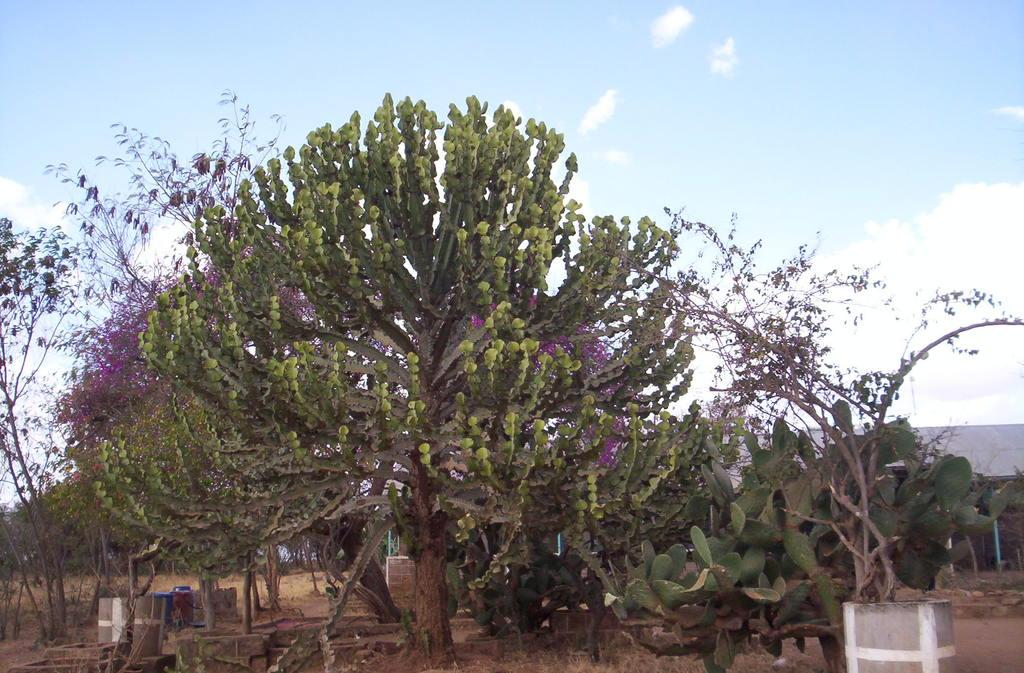What type of vegetation can be seen in the image? There is a group of trees and plants in pots in the image. What else can be seen in the image besides the vegetation? There are poles in the image. What is visible in the sky in the image? The sky is visible in the image and appears cloudy. Where is the harbor located in the image? There is no harbor present in the image. What type of plant is tricking the other plants in the image? There is no plant tricking other plants in the image, as plants do not have the ability to trick each other. 